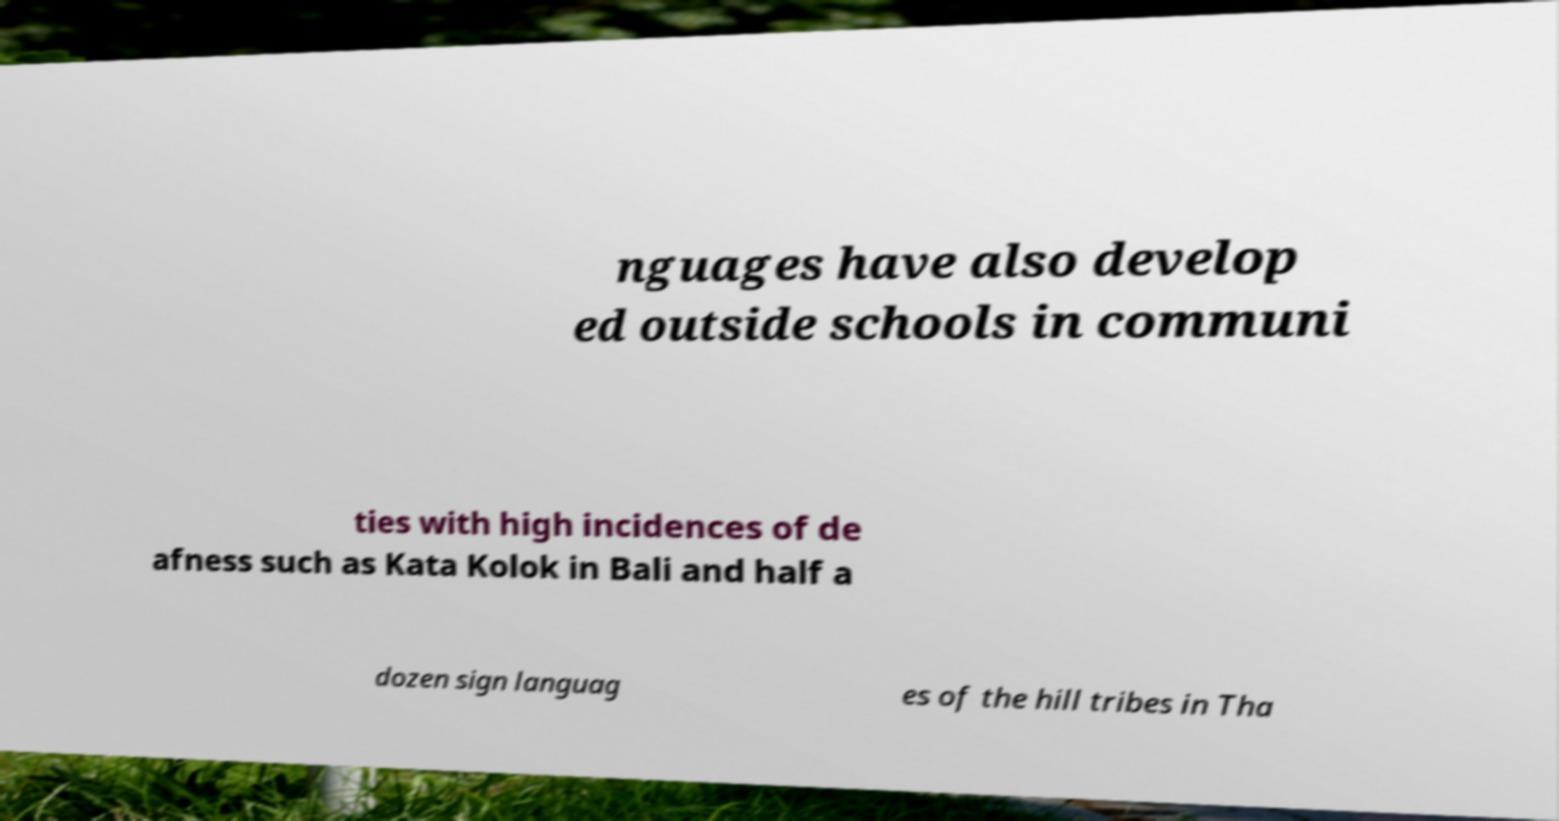What messages or text are displayed in this image? I need them in a readable, typed format. nguages have also develop ed outside schools in communi ties with high incidences of de afness such as Kata Kolok in Bali and half a dozen sign languag es of the hill tribes in Tha 